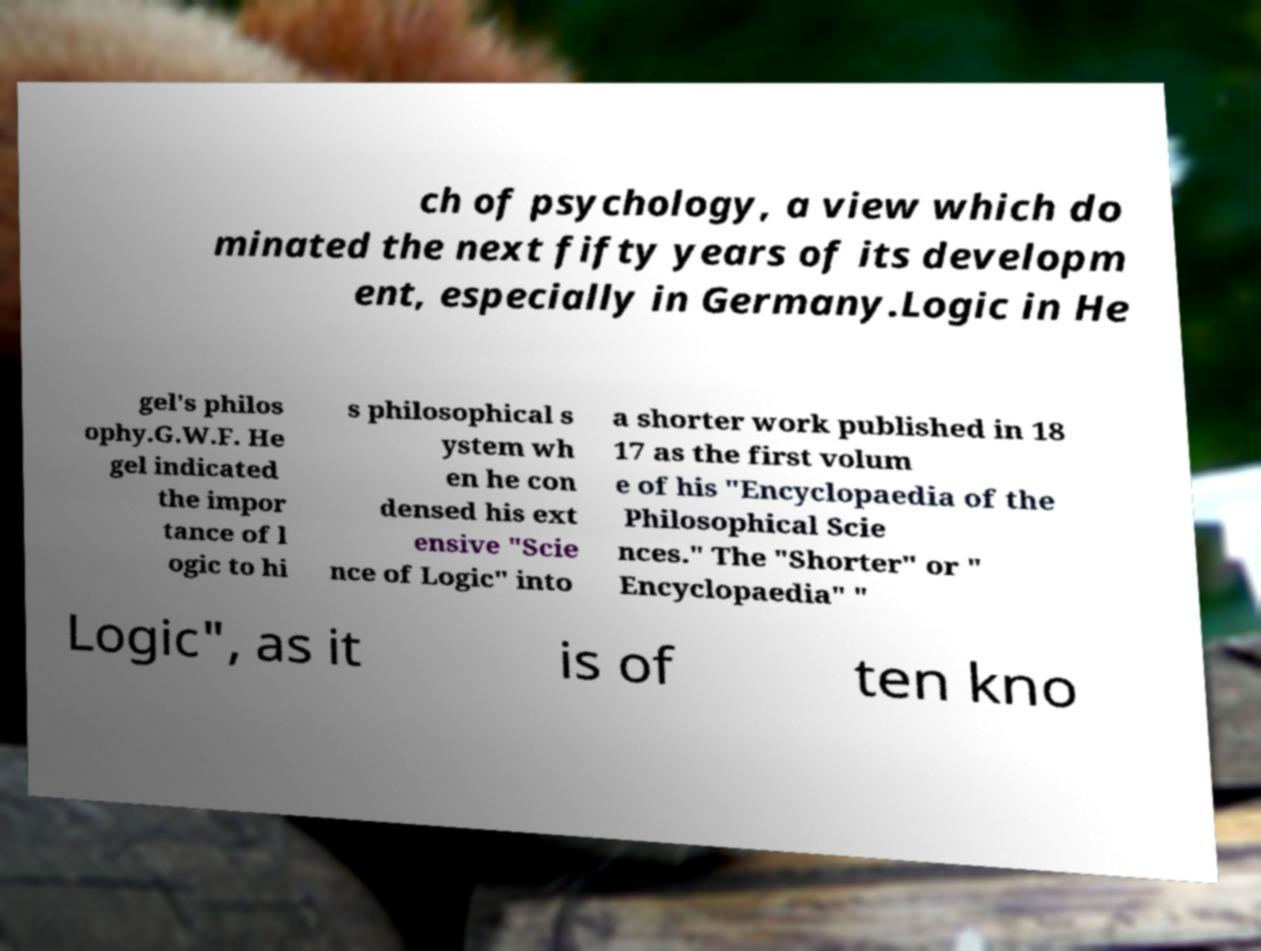Can you read and provide the text displayed in the image?This photo seems to have some interesting text. Can you extract and type it out for me? ch of psychology, a view which do minated the next fifty years of its developm ent, especially in Germany.Logic in He gel's philos ophy.G.W.F. He gel indicated the impor tance of l ogic to hi s philosophical s ystem wh en he con densed his ext ensive "Scie nce of Logic" into a shorter work published in 18 17 as the first volum e of his "Encyclopaedia of the Philosophical Scie nces." The "Shorter" or " Encyclopaedia" " Logic", as it is of ten kno 